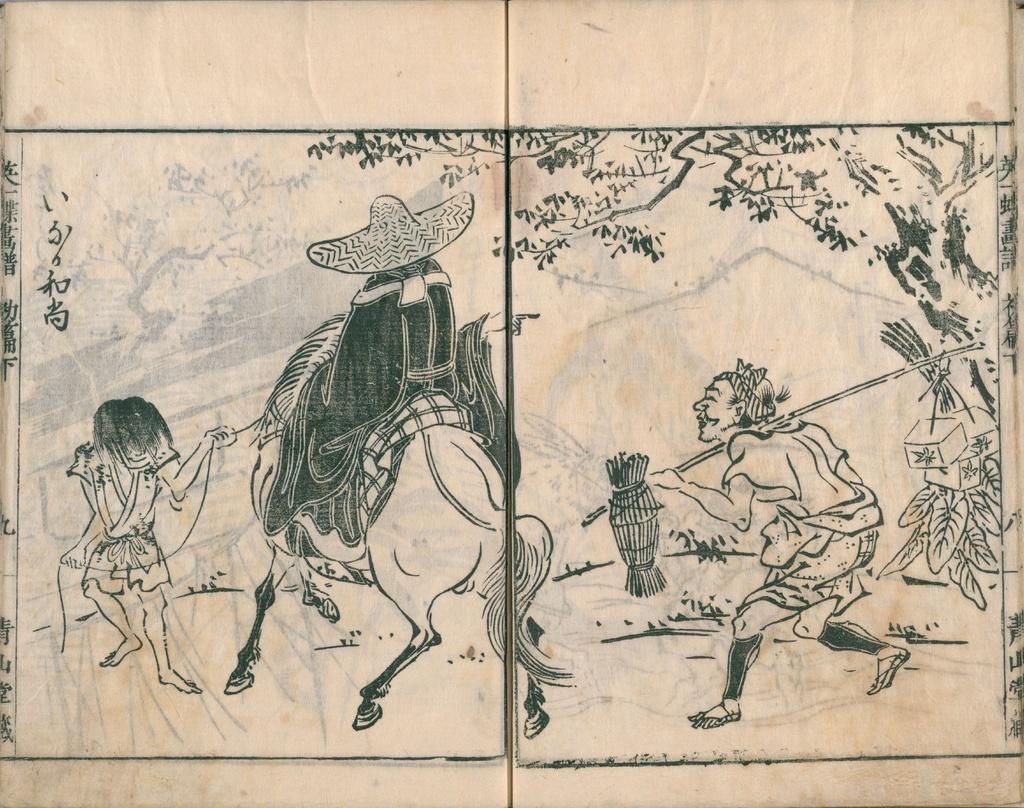How would you summarize this image in a sentence or two? This is a zoomed in picture. In the foreground there is a white color object on which we can see the picture of two persons holding some objects and walking on the ground and we can see the picture of a person riding a horse and we can see the picture of a tree and some other objects. 